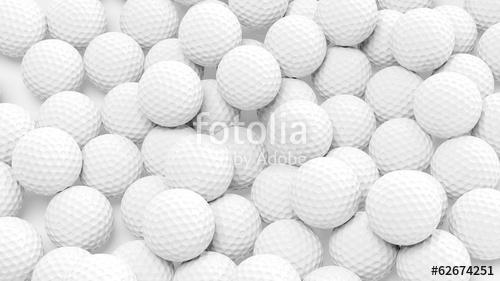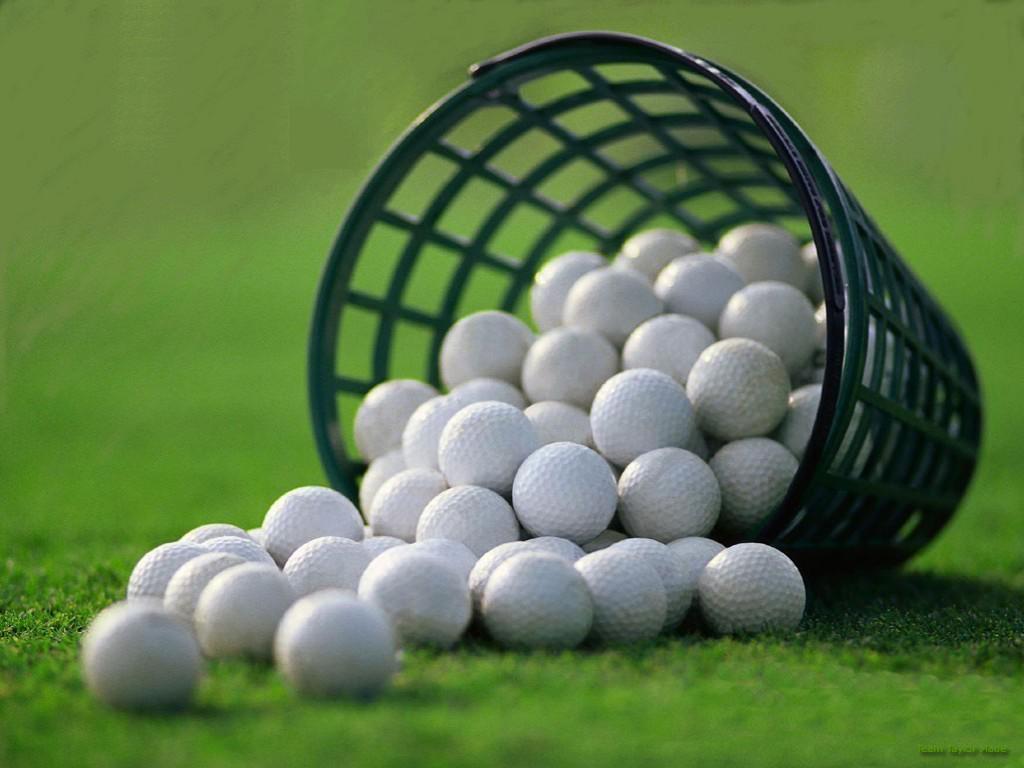The first image is the image on the left, the second image is the image on the right. Evaluate the accuracy of this statement regarding the images: "Balls are pouring out of a mesh green basket.". Is it true? Answer yes or no. Yes. The first image is the image on the left, the second image is the image on the right. Evaluate the accuracy of this statement regarding the images: "An image features a tipped-over mesh-type bucket spilling golf balls.". Is it true? Answer yes or no. Yes. 